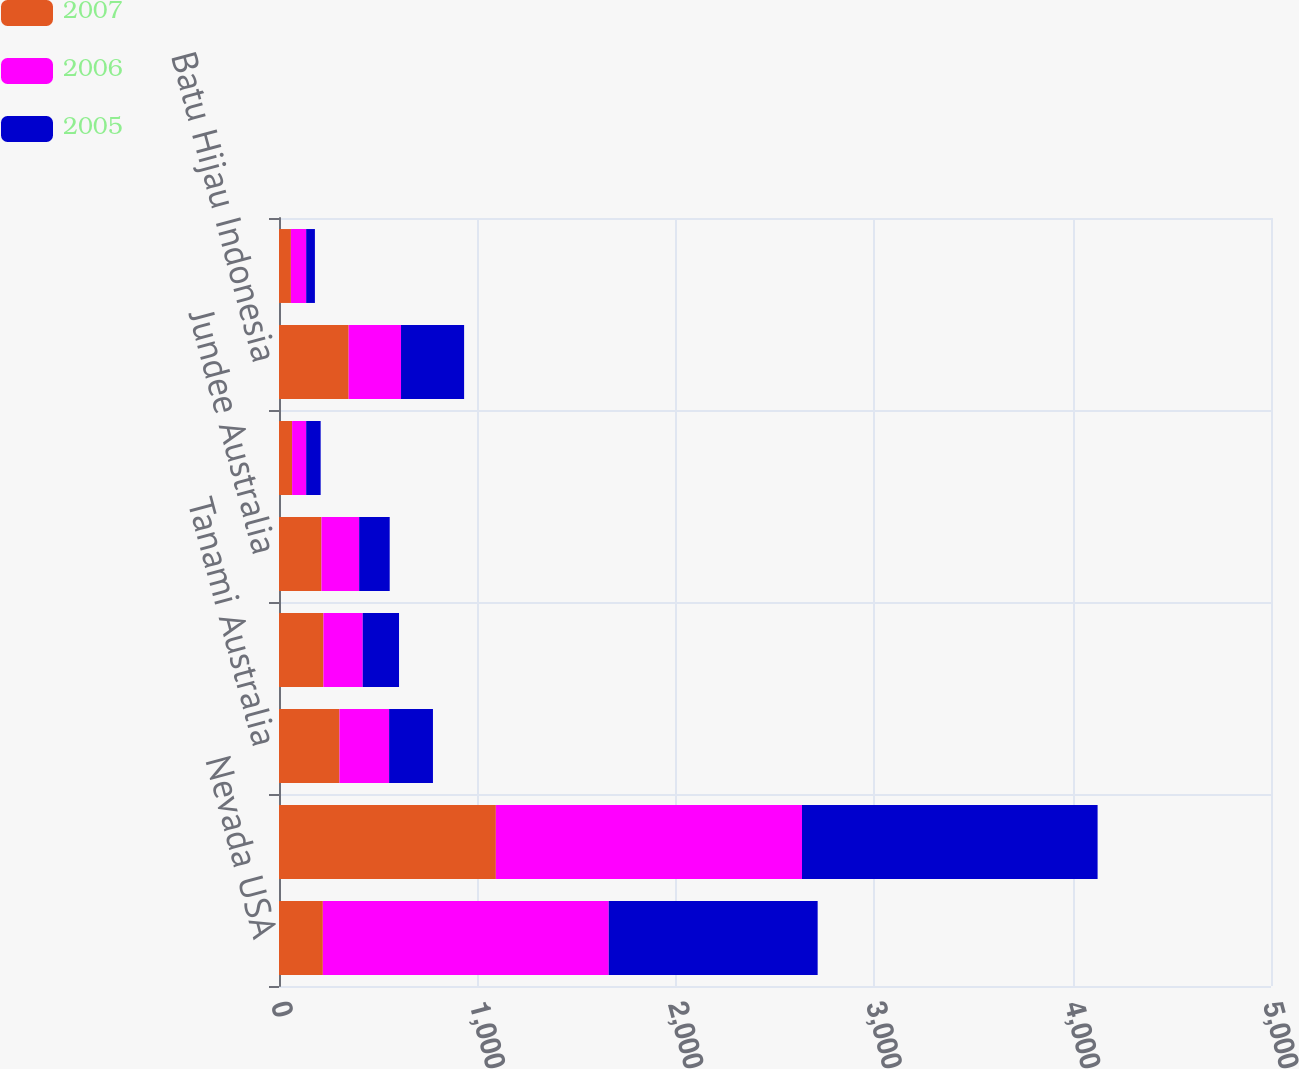Convert chart to OTSL. <chart><loc_0><loc_0><loc_500><loc_500><stacked_bar_chart><ecel><fcel>Nevada USA<fcel>Yanacocha Peru<fcel>Tanami Australia<fcel>Kalgoorlie Australia<fcel>Jundee Australia<fcel>Waihi New Zealand<fcel>Batu Hijau Indonesia<fcel>Kori Kollo Bolivia<nl><fcel>2007<fcel>221<fcel>1093<fcel>305<fcel>224<fcel>214<fcel>66<fcel>351<fcel>60<nl><fcel>2006<fcel>1441<fcel>1543<fcel>250<fcel>198<fcel>190<fcel>71<fcel>264<fcel>77<nl><fcel>2005<fcel>1053<fcel>1490<fcel>221<fcel>183<fcel>154<fcel>73<fcel>318<fcel>44<nl></chart> 